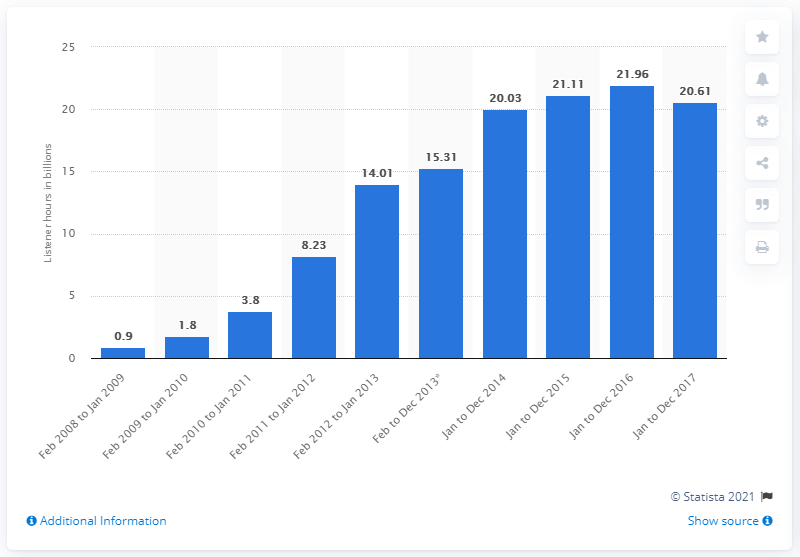Indicate a few pertinent items in this graphic. During the fiscal year ending in December 2017, users listened to a total of 20.61 hours of music. 